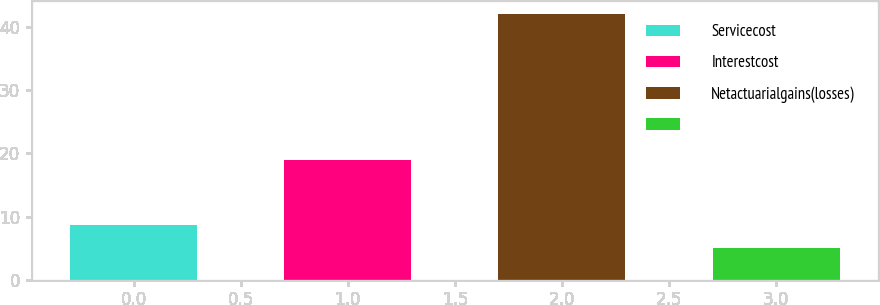Convert chart. <chart><loc_0><loc_0><loc_500><loc_500><bar_chart><fcel>Servicecost<fcel>Interestcost<fcel>Netactuarialgains(losses)<fcel>Unnamed: 3<nl><fcel>8.7<fcel>19<fcel>42<fcel>5<nl></chart> 